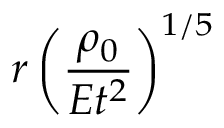<formula> <loc_0><loc_0><loc_500><loc_500>r \left ( { \frac { \rho _ { 0 } } { E t ^ { 2 } } } \right ) ^ { 1 / 5 }</formula> 